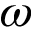<formula> <loc_0><loc_0><loc_500><loc_500>\omega</formula> 